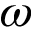<formula> <loc_0><loc_0><loc_500><loc_500>\omega</formula> 